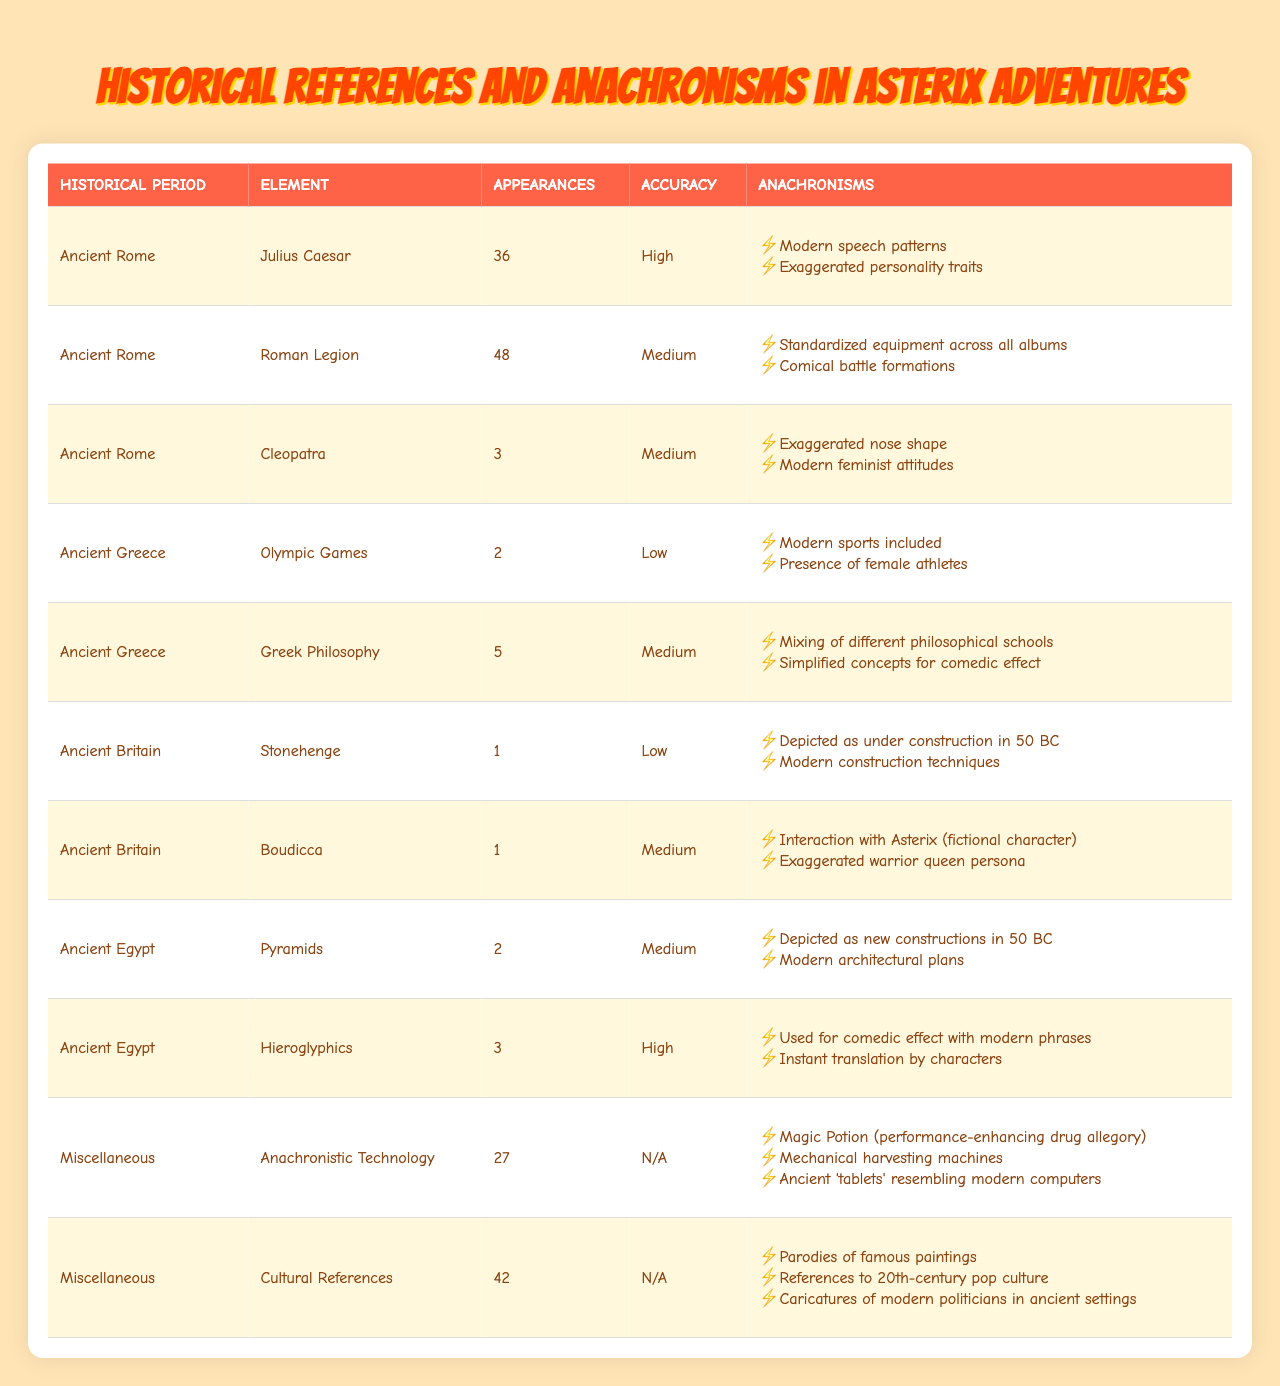What is the total number of appearances for Julius Caesar? In the table, Julius Caesar has an entry showing his appearances as 36.
Answer: 36 Which historical period has the most references? By checking the values under 'Appearances' for each historical period, we can see that the Roman Legion has 48 appearances, which is the highest.
Answer: Ancient Rome How many times is Cleopatra referenced compared to Boudicca? Cleopatra has 3 appearances while Boudicca has 1. The difference is calculated as 3 - 1 = 2.
Answer: Cleopatra is referenced 2 times more than Boudicca Are there any references with a high accuracy rating? Yes, the table shows that both Julius Caesar and Hieroglyphics have a high accuracy rating.
Answer: Yes What is the combined total of appearances for the Olympic Games and Greek Philosophy? The Olympic Games appear 2 times and Greek Philosophy appears 5 times. Adding these gives us 2 + 5 = 7.
Answer: 7 Which historical element has the lowest accuracy rating? The table shows that the Olympic Games have the lowest accuracy rating marked as low.
Answer: Olympic Games How many references are there in Ancient Britain? In Ancient Britain, there are 2 references: Stonehenge and Boudicca.
Answer: 2 Is there anachronism related to modern technology in the 'Miscellaneous' historical period? Yes, references under 'Anachronistic Technology' include examples like mechanical harvesting machines and ancient tablets resembling modern computers, which are related to modern technology.
Answer: Yes What are the anachronisms reported for the Roman Legion? The Roman Legion has two reported anachronisms: standardized equipment across all albums and comical battle formations.
Answer: Standardized equipment and comical battle formations What is the average accuracy rating for all references in Ancient Rome? The references in Ancient Rome have accuracy ratings of high (Caesar), medium (Roman Legion), and medium (Cleopatra). One high is counted as 1, medium as 0.5 each gives a total of 2. Since there are 3 entries, the average is 2/3 ≈ 0.67 or medium.
Answer: Medium 